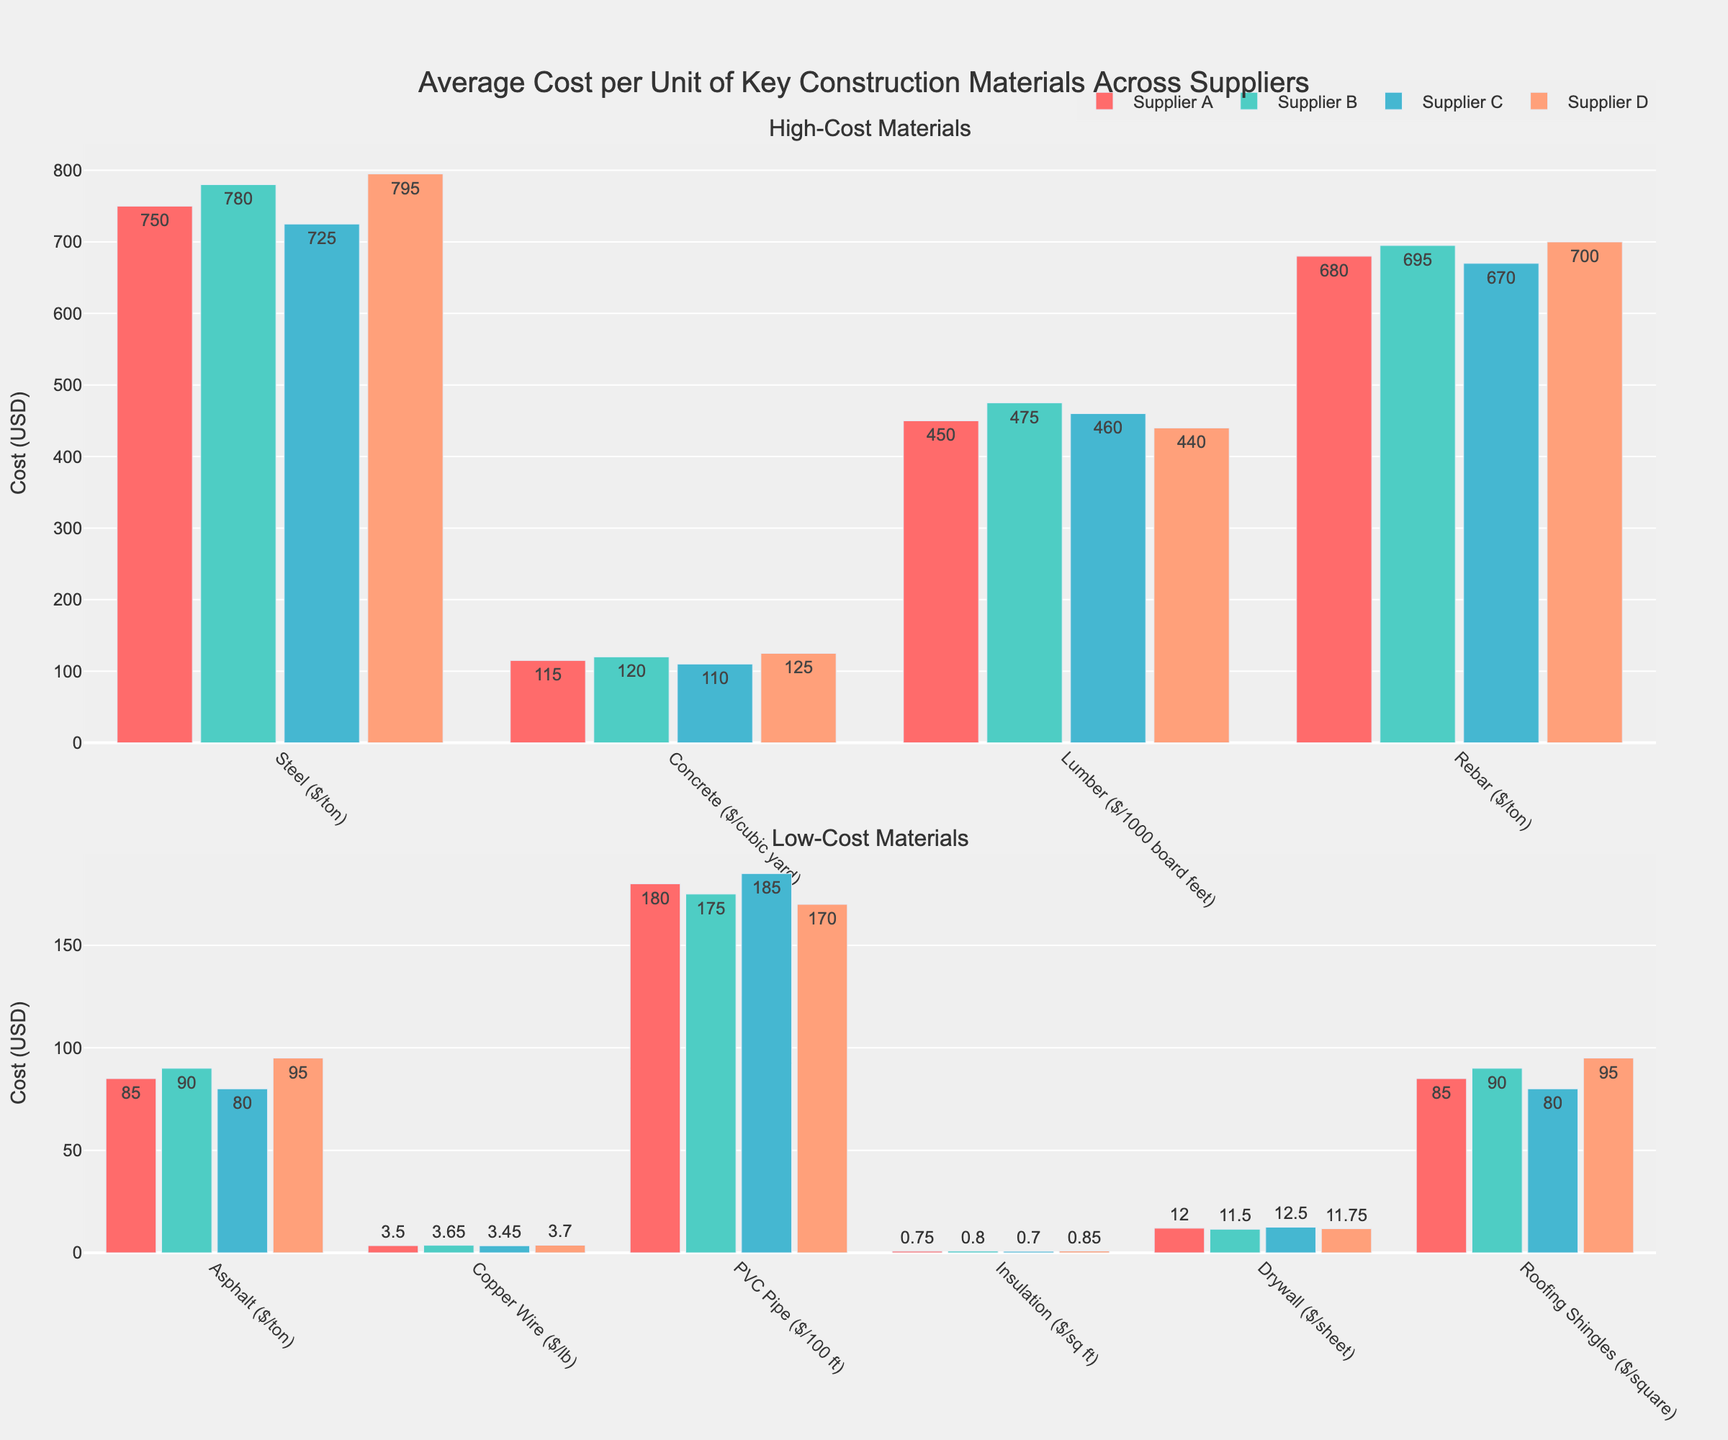Which supplier provides the lowest cost for PVC Pipe? Look at the bar for "PVC Pipe" in the "Low-Cost Materials" section. Supplier D has the shortest bar, indicating the lowest cost.
Answer: Supplier D Which material has the largest cost difference between Supplier A and Supplier D? Compare bars for each material in both sections. For "Steel ($/ton)", the difference is $45, more significant than any other materials.
Answer: Steel ($/ton) What's the average cost of Lumber across all suppliers? Add the costs for Supplier A, B, C, and D for Lumber: (450 + 475 + 460 + 440) = 1825. Divide by 4 to get the average: 1825/4 = 456.25.
Answer: 456.25 Which supplier charges the highest price for Insulation? In the "Low-Cost Materials" section, look at the bar for "Insulation". Supplier D's bar is the tallest.
Answer: Supplier D Is the cost of Concrete for Supplier B greater than the cost of Asphalt for Supplier D? Compare the height of the bar for Supplier B's "Concrete" with that of Supplier D’s "Asphalt" in their respective sections. Supplier B's Concrete cost ($120) is greater than Supplier D’s Asphalt cost ($95).
Answer: Yes By how much does the cost of Copper Wire differ between Supplier B and Supplier C? Find the height of the bars for Copper Wire for Supplier B ($3.65) and Supplier C ($3.45). Subtract to find the difference: 3.65 - 3.45 = 0.2.
Answer: 0.2 Which supplier offers the lowest price for Steel ($/ton) and by how much is it lower compared to the second-lowest? Identify the smallest bar for Steel ($/ton) in the "High-Cost Materials" section. Supplier C offers the lowest price at $725. The second-lowest is Supplier A at $750. The difference is 750 - 725 = 25.
Answer: Supplier C, 25 What’s the total cost of purchasing 1 ton of Steel, 1000 board feet of Lumber, and 1 ton of Rebar from Supplier A? Sum the costs of these materials from Supplier A’s column: (750 + 450 + 680) = 1880.
Answer: 1880 Among the low-cost materials, which has the narrowest cost range across suppliers? Calculate the cost range for each low-cost material by subtracting the lowest price from the highest. Roofing Shingles have a range of 95 - 80 = 15, which is the narrowest among the low-cost materials.
Answer: Roofing Shingles Do any two suppliers offer the same price for Drywall? Check the bars for "Drywall" in the "Low-Cost Materials" section. None of the bars are of equal height, indicating different prices across all suppliers.
Answer: No 